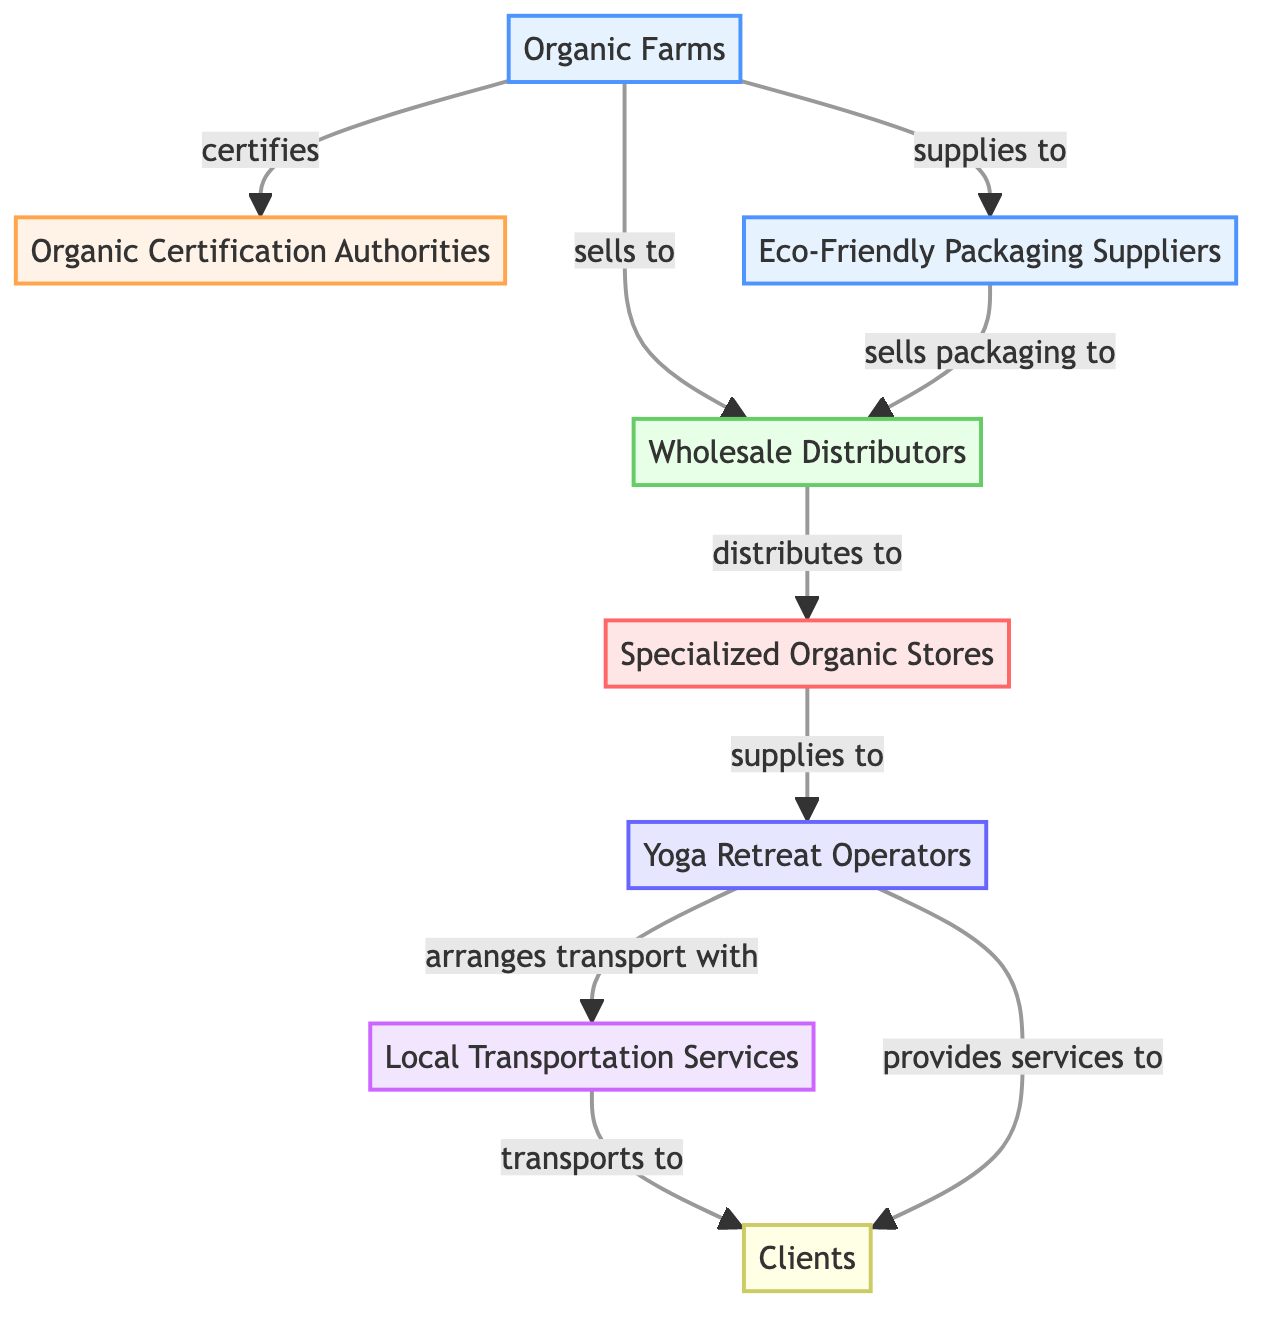What is the total number of nodes in the diagram? The diagram consists of eight distinct entities that are connected to each other, which are represented as nodes. Counting these gives a total of eight nodes.
Answer: 8 Which node certifies organic farms? The "Organic Certification Authorities" node is linked to the "Organic Farms" node with the label "certifies," indicating that it is responsible for certifying the organic farms.
Answer: Organic Certification Authorities How many types of suppliers are present in the diagram? The diagram shows two supplier nodes: "Organic Farms" and "Eco-Friendly Packaging Suppliers." Hence, there are two types of suppliers in the network.
Answer: 2 What is the relationship between wholesale distributors and specialized organic stores? The "Wholesale Distributors" node has a connection to the "Specialized Organic Stores" node marked as "distributes to," indicating that wholesale distributors distribute products to these stores.
Answer: distributes to Who arranges transport services for yoga retreat operators? The "Local Transportation Services" node is linked to the "Yoga Retreat Operators" node with the label "arranges transport with," showing that yoga retreat operators coordinate transport services through this entity.
Answer: Local Transportation Services What is the final destination of the transportation service in the network? The "Clients" node, which is positioned at the end of the transport flow, is the final destination indicated by the connection "transports to" from the "Local Transportation Services."
Answer: Clients Which two nodes are connected by the label "provides services to"? The "Yoga Retreat Operators" node and the "Clients" node share a direct relationship, connected by the label "provides services to," indicating that yoga retreat operators offer services directly to clients.
Answer: Yoga Retreat Operators and Clients How many edges are present in the diagram? The diagram outlines nine distinct relationships or connections between the nodes, which are represented as edges. By counting all the relationships listed, we find a total of nine edges.
Answer: 9 